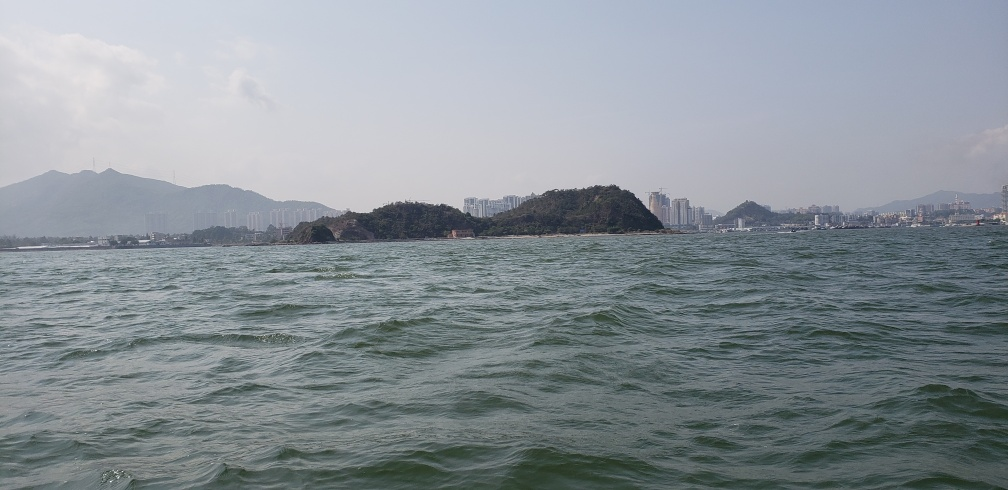Does the photo depict both turbulent waves and calmness? The photo captures a coastal seascape with a noticeable contrast where closer to the foreground, the water appears more dynamic and choppy, suggesting turbulent waves owing to possibly localized winds or boat activity. Further in the background, the water seems calmer around the island and toward the distant mountains, giving a sense of peace that contrasts with the foreground's movement. 